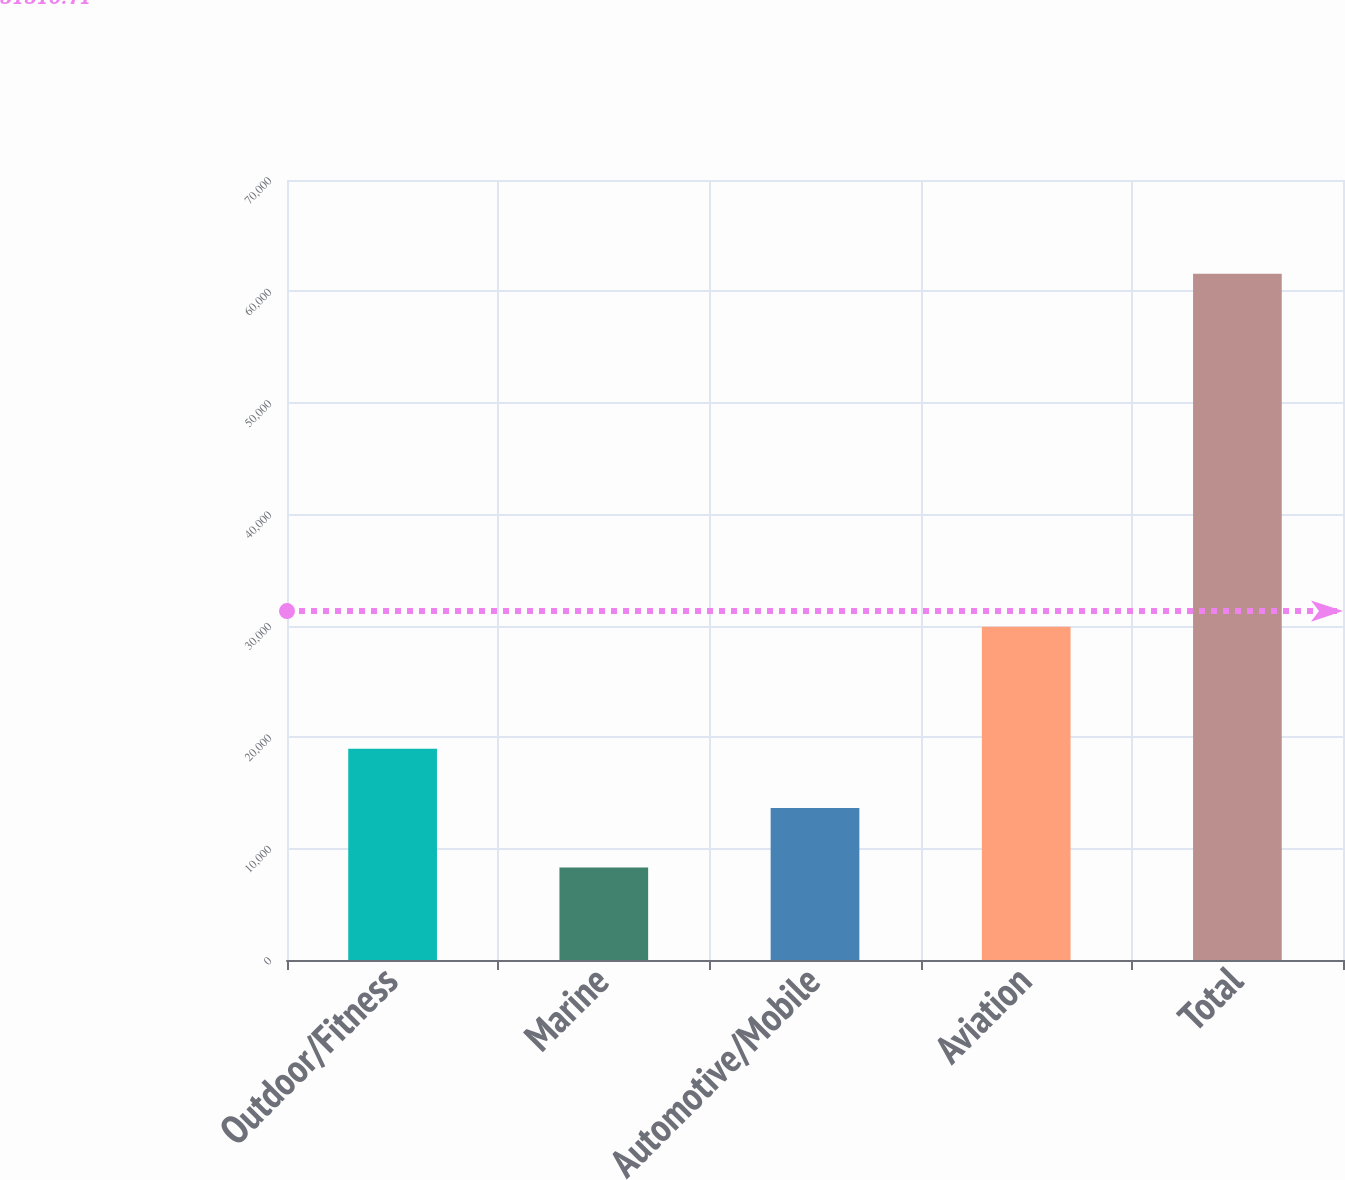Convert chart to OTSL. <chart><loc_0><loc_0><loc_500><loc_500><bar_chart><fcel>Outdoor/Fitness<fcel>Marine<fcel>Automotive/Mobile<fcel>Aviation<fcel>Total<nl><fcel>18963.2<fcel>8309<fcel>13636.1<fcel>29897<fcel>61580<nl></chart> 